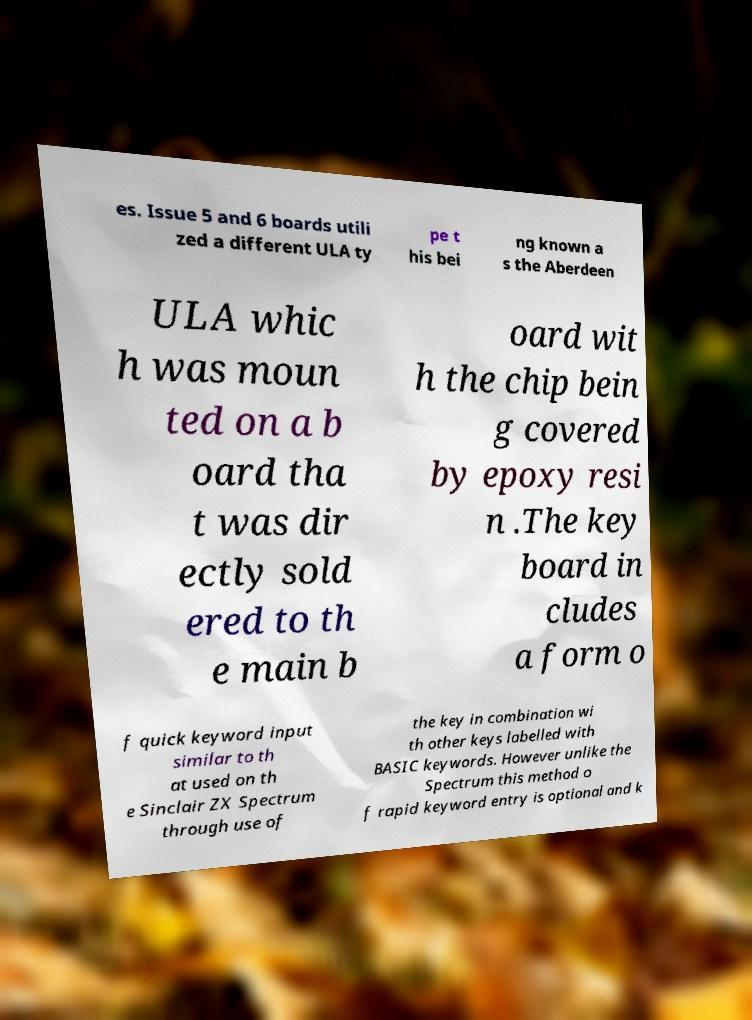Please identify and transcribe the text found in this image. es. Issue 5 and 6 boards utili zed a different ULA ty pe t his bei ng known a s the Aberdeen ULA whic h was moun ted on a b oard tha t was dir ectly sold ered to th e main b oard wit h the chip bein g covered by epoxy resi n .The key board in cludes a form o f quick keyword input similar to th at used on th e Sinclair ZX Spectrum through use of the key in combination wi th other keys labelled with BASIC keywords. However unlike the Spectrum this method o f rapid keyword entry is optional and k 